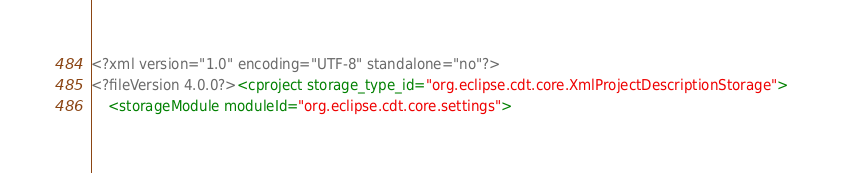<code> <loc_0><loc_0><loc_500><loc_500><_XML_><?xml version="1.0" encoding="UTF-8" standalone="no"?>
<?fileVersion 4.0.0?><cproject storage_type_id="org.eclipse.cdt.core.XmlProjectDescriptionStorage">
	<storageModule moduleId="org.eclipse.cdt.core.settings"></code> 